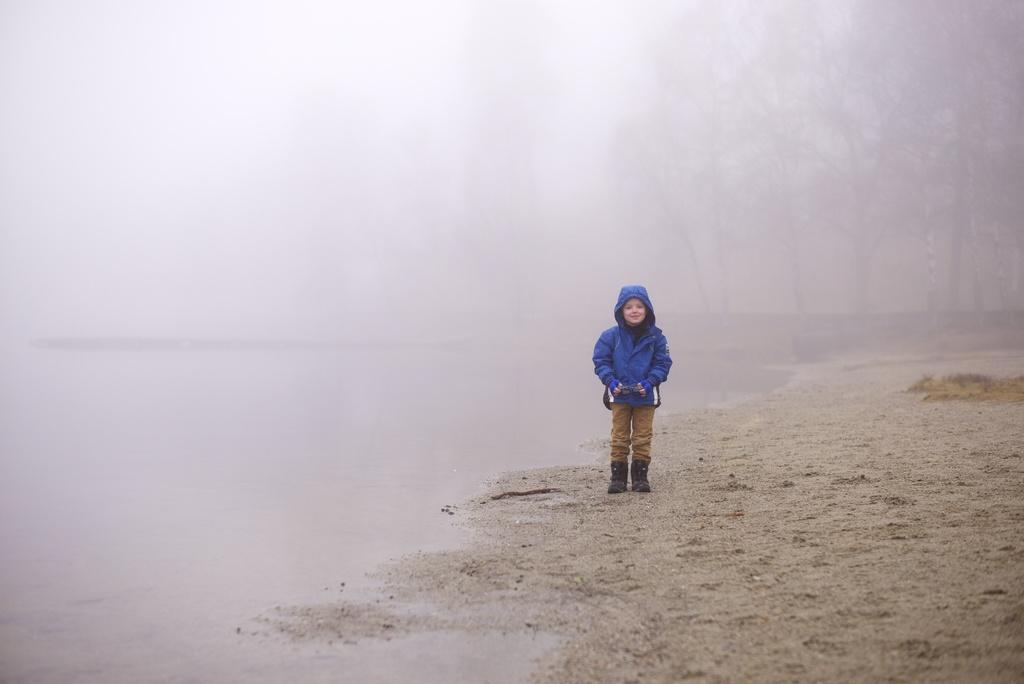In one or two sentences, can you explain what this image depicts? In this image there is a kid standing on a seashore, in the background there are trees and fog. 